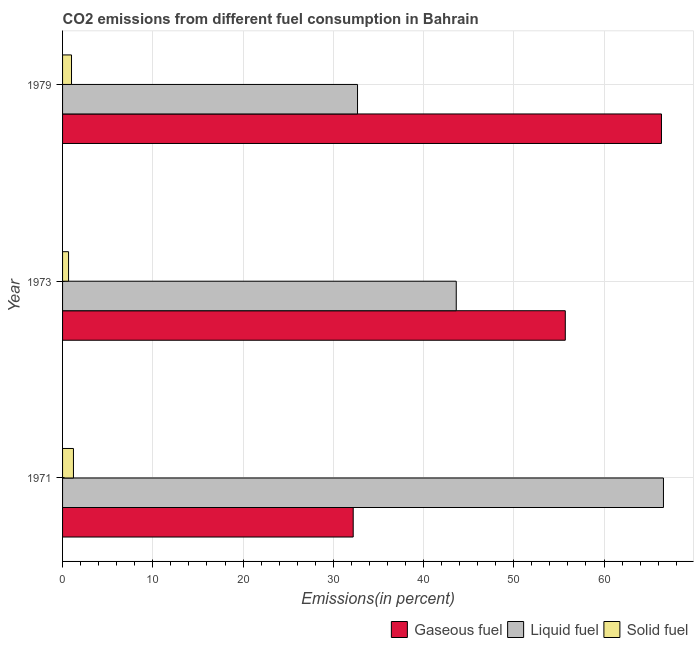How many different coloured bars are there?
Give a very brief answer. 3. How many groups of bars are there?
Your response must be concise. 3. How many bars are there on the 2nd tick from the bottom?
Give a very brief answer. 3. What is the label of the 3rd group of bars from the top?
Your answer should be compact. 1971. What is the percentage of gaseous fuel emission in 1979?
Your answer should be very brief. 66.37. Across all years, what is the maximum percentage of solid fuel emission?
Ensure brevity in your answer.  1.21. Across all years, what is the minimum percentage of gaseous fuel emission?
Your response must be concise. 32.21. In which year was the percentage of gaseous fuel emission maximum?
Provide a succinct answer. 1979. In which year was the percentage of liquid fuel emission minimum?
Give a very brief answer. 1979. What is the total percentage of solid fuel emission in the graph?
Your answer should be very brief. 2.86. What is the difference between the percentage of gaseous fuel emission in 1971 and that in 1979?
Your response must be concise. -34.16. What is the difference between the percentage of gaseous fuel emission in 1979 and the percentage of liquid fuel emission in 1973?
Offer a very short reply. 22.74. What is the average percentage of gaseous fuel emission per year?
Keep it short and to the point. 51.43. In the year 1971, what is the difference between the percentage of liquid fuel emission and percentage of gaseous fuel emission?
Your answer should be very brief. 34.38. In how many years, is the percentage of solid fuel emission greater than 48 %?
Provide a succinct answer. 0. What is the ratio of the percentage of gaseous fuel emission in 1971 to that in 1973?
Provide a succinct answer. 0.58. Is the difference between the percentage of liquid fuel emission in 1973 and 1979 greater than the difference between the percentage of solid fuel emission in 1973 and 1979?
Give a very brief answer. Yes. What is the difference between the highest and the second highest percentage of solid fuel emission?
Your answer should be compact. 0.21. What is the difference between the highest and the lowest percentage of solid fuel emission?
Your answer should be very brief. 0.54. In how many years, is the percentage of liquid fuel emission greater than the average percentage of liquid fuel emission taken over all years?
Your answer should be compact. 1. Is the sum of the percentage of solid fuel emission in 1971 and 1973 greater than the maximum percentage of gaseous fuel emission across all years?
Provide a succinct answer. No. What does the 3rd bar from the top in 1979 represents?
Offer a very short reply. Gaseous fuel. What does the 3rd bar from the bottom in 1971 represents?
Ensure brevity in your answer.  Solid fuel. How many bars are there?
Keep it short and to the point. 9. How many years are there in the graph?
Give a very brief answer. 3. Does the graph contain any zero values?
Make the answer very short. No. Does the graph contain grids?
Make the answer very short. Yes. Where does the legend appear in the graph?
Keep it short and to the point. Bottom right. How many legend labels are there?
Your answer should be very brief. 3. What is the title of the graph?
Offer a very short reply. CO2 emissions from different fuel consumption in Bahrain. What is the label or title of the X-axis?
Make the answer very short. Emissions(in percent). What is the Emissions(in percent) of Gaseous fuel in 1971?
Offer a very short reply. 32.21. What is the Emissions(in percent) in Liquid fuel in 1971?
Ensure brevity in your answer.  66.59. What is the Emissions(in percent) of Solid fuel in 1971?
Offer a very short reply. 1.21. What is the Emissions(in percent) in Gaseous fuel in 1973?
Your answer should be compact. 55.71. What is the Emissions(in percent) of Liquid fuel in 1973?
Provide a short and direct response. 43.63. What is the Emissions(in percent) of Solid fuel in 1973?
Your answer should be very brief. 0.66. What is the Emissions(in percent) of Gaseous fuel in 1979?
Keep it short and to the point. 66.37. What is the Emissions(in percent) of Liquid fuel in 1979?
Provide a succinct answer. 32.69. What is the Emissions(in percent) in Solid fuel in 1979?
Offer a very short reply. 0.99. Across all years, what is the maximum Emissions(in percent) of Gaseous fuel?
Your answer should be compact. 66.37. Across all years, what is the maximum Emissions(in percent) of Liquid fuel?
Provide a short and direct response. 66.59. Across all years, what is the maximum Emissions(in percent) of Solid fuel?
Provide a short and direct response. 1.21. Across all years, what is the minimum Emissions(in percent) in Gaseous fuel?
Provide a succinct answer. 32.21. Across all years, what is the minimum Emissions(in percent) of Liquid fuel?
Your answer should be very brief. 32.69. Across all years, what is the minimum Emissions(in percent) in Solid fuel?
Your answer should be very brief. 0.66. What is the total Emissions(in percent) in Gaseous fuel in the graph?
Provide a succinct answer. 154.28. What is the total Emissions(in percent) in Liquid fuel in the graph?
Make the answer very short. 142.9. What is the total Emissions(in percent) in Solid fuel in the graph?
Offer a very short reply. 2.86. What is the difference between the Emissions(in percent) of Gaseous fuel in 1971 and that in 1973?
Your response must be concise. -23.5. What is the difference between the Emissions(in percent) in Liquid fuel in 1971 and that in 1973?
Offer a terse response. 22.96. What is the difference between the Emissions(in percent) of Solid fuel in 1971 and that in 1973?
Your answer should be very brief. 0.54. What is the difference between the Emissions(in percent) of Gaseous fuel in 1971 and that in 1979?
Keep it short and to the point. -34.16. What is the difference between the Emissions(in percent) of Liquid fuel in 1971 and that in 1979?
Ensure brevity in your answer.  33.9. What is the difference between the Emissions(in percent) in Solid fuel in 1971 and that in 1979?
Make the answer very short. 0.21. What is the difference between the Emissions(in percent) in Gaseous fuel in 1973 and that in 1979?
Your answer should be compact. -10.66. What is the difference between the Emissions(in percent) in Liquid fuel in 1973 and that in 1979?
Provide a succinct answer. 10.94. What is the difference between the Emissions(in percent) of Solid fuel in 1973 and that in 1979?
Provide a short and direct response. -0.33. What is the difference between the Emissions(in percent) of Gaseous fuel in 1971 and the Emissions(in percent) of Liquid fuel in 1973?
Your answer should be very brief. -11.42. What is the difference between the Emissions(in percent) in Gaseous fuel in 1971 and the Emissions(in percent) in Solid fuel in 1973?
Your answer should be very brief. 31.54. What is the difference between the Emissions(in percent) of Liquid fuel in 1971 and the Emissions(in percent) of Solid fuel in 1973?
Make the answer very short. 65.92. What is the difference between the Emissions(in percent) of Gaseous fuel in 1971 and the Emissions(in percent) of Liquid fuel in 1979?
Offer a very short reply. -0.48. What is the difference between the Emissions(in percent) of Gaseous fuel in 1971 and the Emissions(in percent) of Solid fuel in 1979?
Offer a terse response. 31.22. What is the difference between the Emissions(in percent) in Liquid fuel in 1971 and the Emissions(in percent) in Solid fuel in 1979?
Make the answer very short. 65.59. What is the difference between the Emissions(in percent) in Gaseous fuel in 1973 and the Emissions(in percent) in Liquid fuel in 1979?
Offer a very short reply. 23.02. What is the difference between the Emissions(in percent) in Gaseous fuel in 1973 and the Emissions(in percent) in Solid fuel in 1979?
Your response must be concise. 54.72. What is the difference between the Emissions(in percent) in Liquid fuel in 1973 and the Emissions(in percent) in Solid fuel in 1979?
Your answer should be very brief. 42.63. What is the average Emissions(in percent) in Gaseous fuel per year?
Keep it short and to the point. 51.43. What is the average Emissions(in percent) in Liquid fuel per year?
Your answer should be very brief. 47.63. What is the average Emissions(in percent) in Solid fuel per year?
Your response must be concise. 0.95. In the year 1971, what is the difference between the Emissions(in percent) in Gaseous fuel and Emissions(in percent) in Liquid fuel?
Offer a terse response. -34.38. In the year 1971, what is the difference between the Emissions(in percent) in Gaseous fuel and Emissions(in percent) in Solid fuel?
Your response must be concise. 31. In the year 1971, what is the difference between the Emissions(in percent) of Liquid fuel and Emissions(in percent) of Solid fuel?
Your answer should be compact. 65.38. In the year 1973, what is the difference between the Emissions(in percent) of Gaseous fuel and Emissions(in percent) of Liquid fuel?
Offer a terse response. 12.09. In the year 1973, what is the difference between the Emissions(in percent) in Gaseous fuel and Emissions(in percent) in Solid fuel?
Provide a succinct answer. 55.05. In the year 1973, what is the difference between the Emissions(in percent) of Liquid fuel and Emissions(in percent) of Solid fuel?
Provide a short and direct response. 42.96. In the year 1979, what is the difference between the Emissions(in percent) of Gaseous fuel and Emissions(in percent) of Liquid fuel?
Your response must be concise. 33.68. In the year 1979, what is the difference between the Emissions(in percent) of Gaseous fuel and Emissions(in percent) of Solid fuel?
Make the answer very short. 65.37. In the year 1979, what is the difference between the Emissions(in percent) in Liquid fuel and Emissions(in percent) in Solid fuel?
Offer a very short reply. 31.7. What is the ratio of the Emissions(in percent) of Gaseous fuel in 1971 to that in 1973?
Keep it short and to the point. 0.58. What is the ratio of the Emissions(in percent) of Liquid fuel in 1971 to that in 1973?
Provide a short and direct response. 1.53. What is the ratio of the Emissions(in percent) of Solid fuel in 1971 to that in 1973?
Give a very brief answer. 1.82. What is the ratio of the Emissions(in percent) in Gaseous fuel in 1971 to that in 1979?
Give a very brief answer. 0.49. What is the ratio of the Emissions(in percent) in Liquid fuel in 1971 to that in 1979?
Ensure brevity in your answer.  2.04. What is the ratio of the Emissions(in percent) in Solid fuel in 1971 to that in 1979?
Offer a very short reply. 1.22. What is the ratio of the Emissions(in percent) of Gaseous fuel in 1973 to that in 1979?
Give a very brief answer. 0.84. What is the ratio of the Emissions(in percent) in Liquid fuel in 1973 to that in 1979?
Make the answer very short. 1.33. What is the ratio of the Emissions(in percent) in Solid fuel in 1973 to that in 1979?
Your answer should be very brief. 0.67. What is the difference between the highest and the second highest Emissions(in percent) in Gaseous fuel?
Your answer should be compact. 10.66. What is the difference between the highest and the second highest Emissions(in percent) in Liquid fuel?
Provide a short and direct response. 22.96. What is the difference between the highest and the second highest Emissions(in percent) of Solid fuel?
Keep it short and to the point. 0.21. What is the difference between the highest and the lowest Emissions(in percent) in Gaseous fuel?
Provide a succinct answer. 34.16. What is the difference between the highest and the lowest Emissions(in percent) in Liquid fuel?
Your answer should be compact. 33.9. What is the difference between the highest and the lowest Emissions(in percent) of Solid fuel?
Keep it short and to the point. 0.54. 